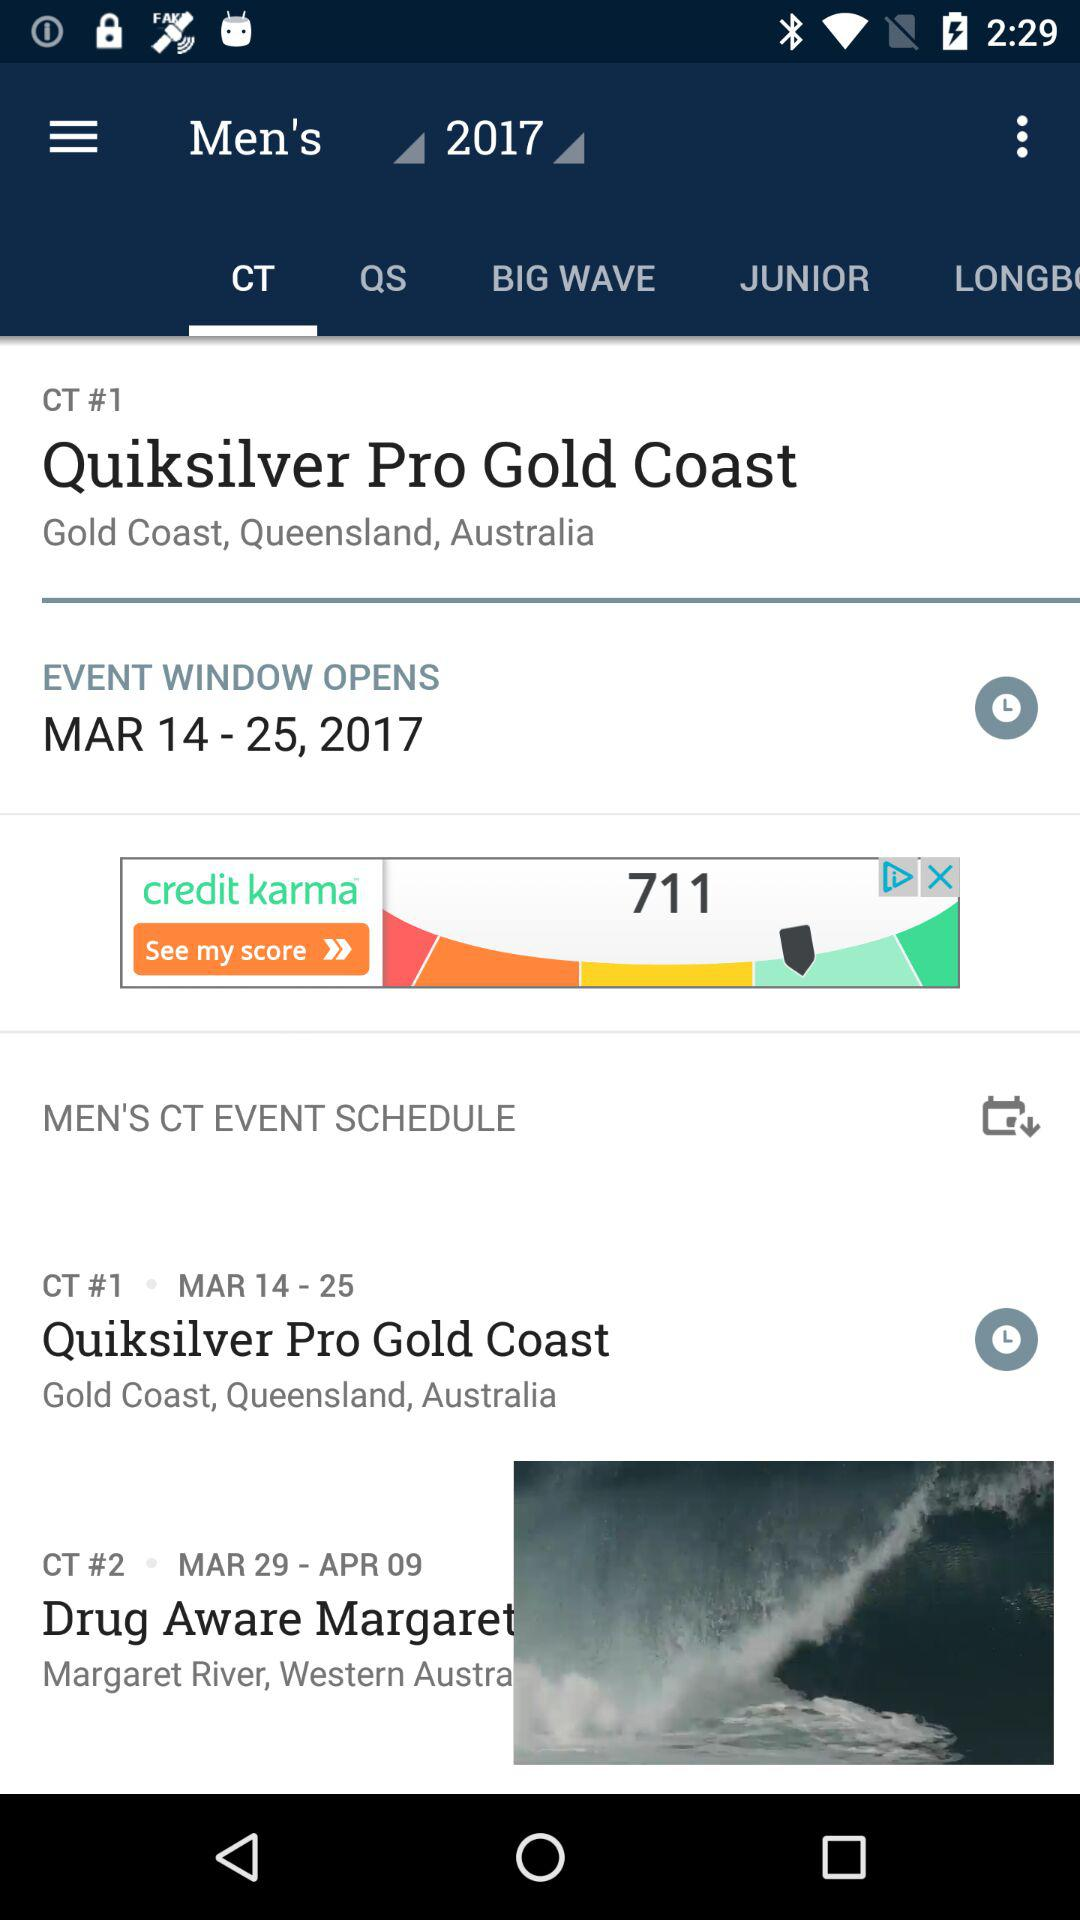Which other options are available other than "Men's"?
When the provided information is insufficient, respond with <no answer>. <no answer> 